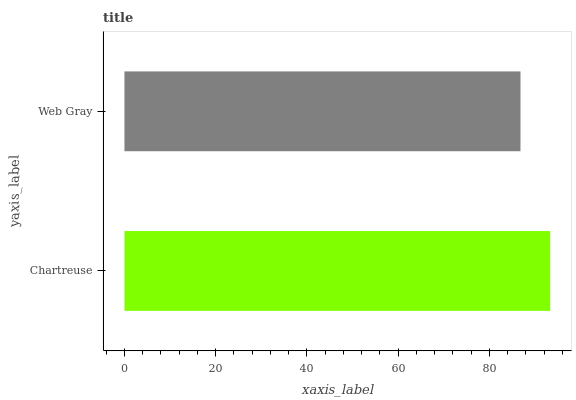Is Web Gray the minimum?
Answer yes or no. Yes. Is Chartreuse the maximum?
Answer yes or no. Yes. Is Web Gray the maximum?
Answer yes or no. No. Is Chartreuse greater than Web Gray?
Answer yes or no. Yes. Is Web Gray less than Chartreuse?
Answer yes or no. Yes. Is Web Gray greater than Chartreuse?
Answer yes or no. No. Is Chartreuse less than Web Gray?
Answer yes or no. No. Is Chartreuse the high median?
Answer yes or no. Yes. Is Web Gray the low median?
Answer yes or no. Yes. Is Web Gray the high median?
Answer yes or no. No. Is Chartreuse the low median?
Answer yes or no. No. 